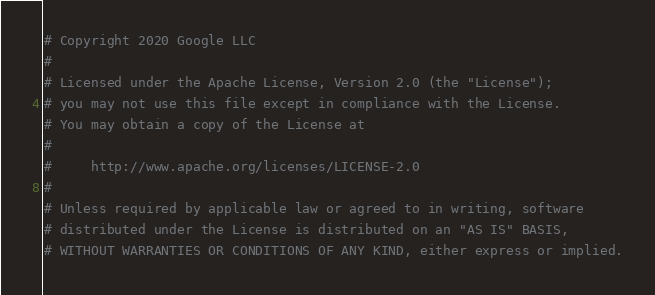<code> <loc_0><loc_0><loc_500><loc_500><_Python_># Copyright 2020 Google LLC
#
# Licensed under the Apache License, Version 2.0 (the "License");
# you may not use this file except in compliance with the License.
# You may obtain a copy of the License at
#
#     http://www.apache.org/licenses/LICENSE-2.0
#
# Unless required by applicable law or agreed to in writing, software
# distributed under the License is distributed on an "AS IS" BASIS,
# WITHOUT WARRANTIES OR CONDITIONS OF ANY KIND, either express or implied.</code> 